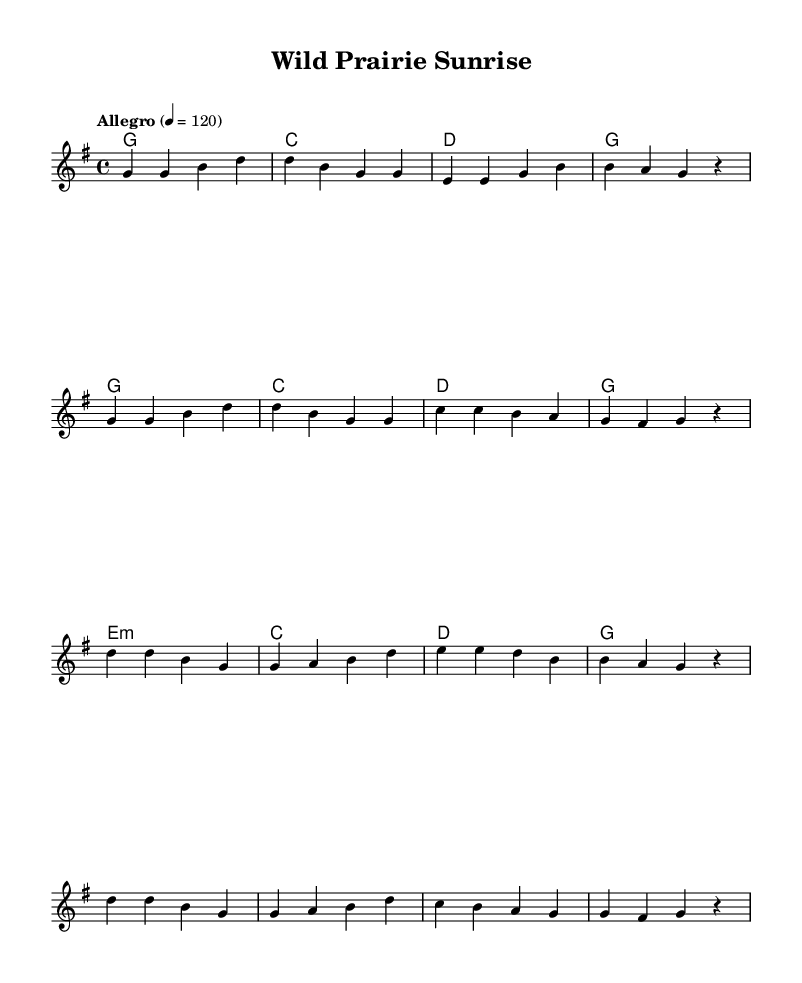What is the key signature of this music? The key signature is G major, which has one sharp. This can be determined by looking at the key declaration at the beginning of the score, which indicates the use of F# notes throughout.
Answer: G major What is the time signature of this music? The time signature is 4/4, indicated at the beginning of the piece. This shows that there are four beats in each measure, and the quarter note gets one beat.
Answer: 4/4 What is the tempo marking for this piece? The tempo marking indicated is "Allegro" with a metronome mark of 120. This indicates that the piece should be played quickly at a speed of 120 beats per minute, which is typical for upbeat country tunes.
Answer: Allegro, 120 How many measures are in the verse section? The verse section contains 8 measures. This can be seen by counting the groups of notes and bars in the melody part labeled as "Verse".
Answer: 8 What chords are used in the chorus? The chorus uses the chords G, C, D, and E minor. These chords are shown in the chord mode section for the chorus part and indicate the harmonic progression typical for country music.
Answer: G, C, D, E minor What is the last note of the melody? The last note of the melody is a rest. This is found at the end of the melody line, indicating a pause in sound, which is common in musical phrases.
Answer: rest Why is this piece categorized as an upbeat country tune? The characteristics of the piece, such as the fast tempo (Allegro), major key, and lively rhythm combined with themes of nature and wildlife, contribute to its classification as an upbeat country tune. Additionally, the structure and chord progressions reflect common conventions found in country music.
Answer: Upbeat country tune 